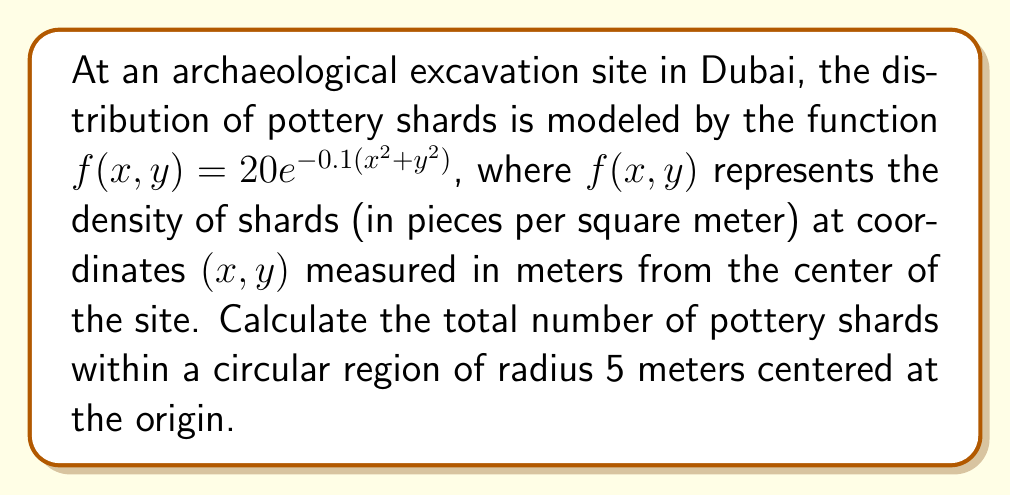Can you answer this question? To solve this problem, we need to use double integration in polar coordinates:

1) First, we convert the function to polar coordinates:
   $x = r\cos(\theta)$, $y = r\sin(\theta)$
   $f(r,\theta) = 20e^{-0.1(r^2\cos^2(\theta)+r^2\sin^2(\theta))} = 20e^{-0.1r^2}$

2) The total number of shards is the volume under the surface $f(r,\theta)$ over the circular region. We can calculate this using a double integral:

   $$N = \int_0^{2\pi} \int_0^5 f(r,\theta) r dr d\theta$$

3) Substituting our function:

   $$N = \int_0^{2\pi} \int_0^5 20e^{-0.1r^2} r dr d\theta$$

4) The inner integral doesn't depend on $\theta$, so we can separate the integrals:

   $$N = 2\pi \int_0^5 20re^{-0.1r^2} dr$$

5) To solve this integral, we use the substitution $u = -0.1r^2$, $du = -0.2r dr$:

   $$N = 2\pi \cdot (-100) \int_{-2.5}^0 e^u du = -200\pi [e^u]_{-2.5}^0$$

6) Evaluating the integral:

   $$N = -200\pi (1 - e^{-2.5})$$

7) Simplifying:

   $$N = 200\pi (e^{-2.5} - 1) \approx 1201.14$$

Thus, there are approximately 1201 pottery shards within the 5-meter radius.
Answer: $200\pi (e^{-2.5} - 1) \approx 1201$ shards 